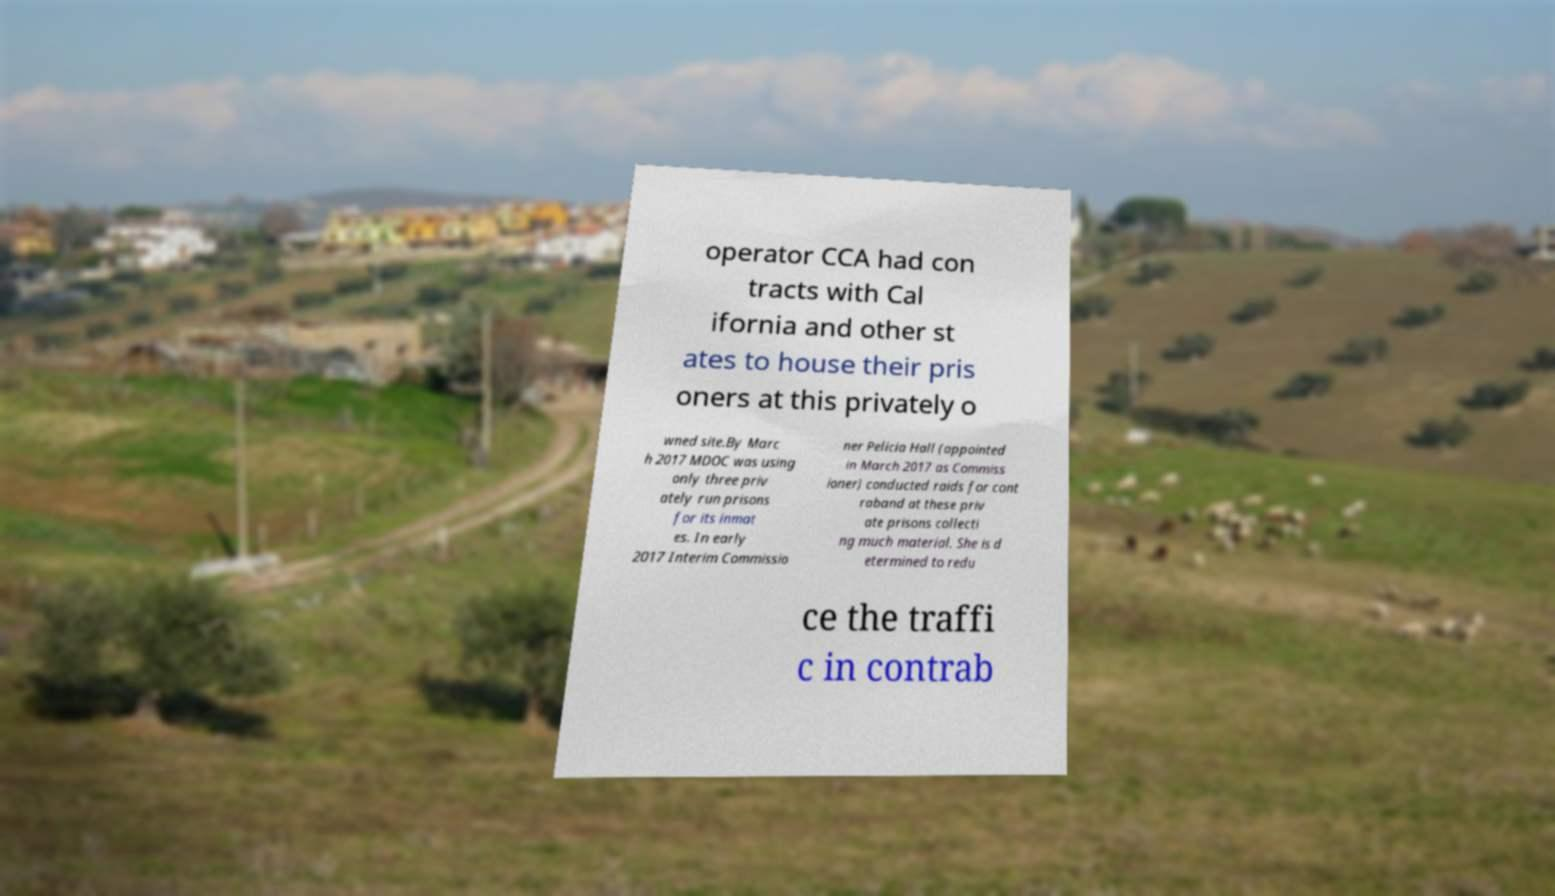What messages or text are displayed in this image? I need them in a readable, typed format. operator CCA had con tracts with Cal ifornia and other st ates to house their pris oners at this privately o wned site.By Marc h 2017 MDOC was using only three priv ately run prisons for its inmat es. In early 2017 Interim Commissio ner Pelicia Hall (appointed in March 2017 as Commiss ioner) conducted raids for cont raband at these priv ate prisons collecti ng much material. She is d etermined to redu ce the traffi c in contrab 